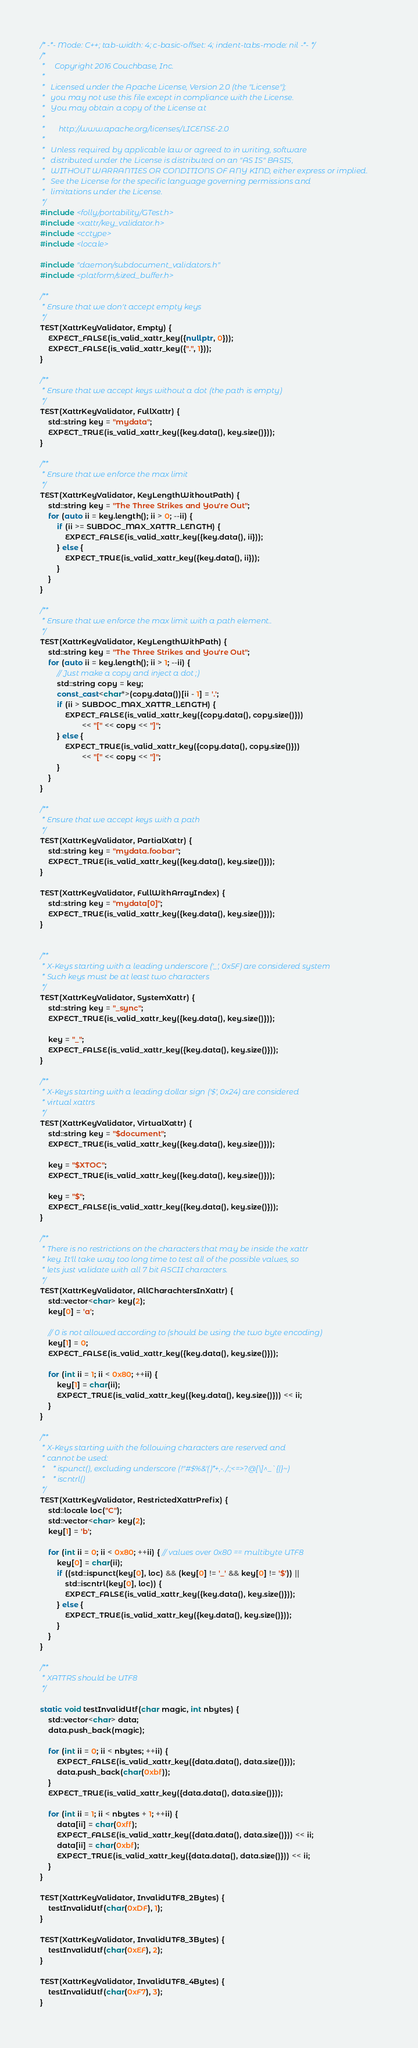<code> <loc_0><loc_0><loc_500><loc_500><_C++_>/* -*- Mode: C++; tab-width: 4; c-basic-offset: 4; indent-tabs-mode: nil -*- */
/*
 *     Copyright 2016 Couchbase, Inc.
 *
 *   Licensed under the Apache License, Version 2.0 (the "License");
 *   you may not use this file except in compliance with the License.
 *   You may obtain a copy of the License at
 *
 *       http://www.apache.org/licenses/LICENSE-2.0
 *
 *   Unless required by applicable law or agreed to in writing, software
 *   distributed under the License is distributed on an "AS IS" BASIS,
 *   WITHOUT WARRANTIES OR CONDITIONS OF ANY KIND, either express or implied.
 *   See the License for the specific language governing permissions and
 *   limitations under the License.
 */
#include <folly/portability/GTest.h>
#include <xattr/key_validator.h>
#include <cctype>
#include <locale>

#include "daemon/subdocument_validators.h"
#include <platform/sized_buffer.h>

/**
 * Ensure that we don't accept empty keys
 */
TEST(XattrKeyValidator, Empty) {
    EXPECT_FALSE(is_valid_xattr_key({nullptr, 0}));
    EXPECT_FALSE(is_valid_xattr_key({".", 1}));
}

/**
 * Ensure that we accept keys without a dot (the path is empty)
 */
TEST(XattrKeyValidator, FullXattr) {
    std::string key = "mydata";
    EXPECT_TRUE(is_valid_xattr_key({key.data(), key.size()}));
}

/**
 * Ensure that we enforce the max limit
 */
TEST(XattrKeyValidator, KeyLengthWithoutPath) {
    std::string key = "The Three Strikes and You're Out";
    for (auto ii = key.length(); ii > 0; --ii) {
        if (ii >= SUBDOC_MAX_XATTR_LENGTH) {
            EXPECT_FALSE(is_valid_xattr_key({key.data(), ii}));
        } else {
            EXPECT_TRUE(is_valid_xattr_key({key.data(), ii}));
        }
    }
}

/**
 * Ensure that we enforce the max limit with a path element..
 */
TEST(XattrKeyValidator, KeyLengthWithPath) {
    std::string key = "The Three Strikes and You're Out";
    for (auto ii = key.length(); ii > 1; --ii) {
        // Just make a copy and inject a dot ;)
        std::string copy = key;
        const_cast<char*>(copy.data())[ii - 1] = '.';
        if (ii > SUBDOC_MAX_XATTR_LENGTH) {
            EXPECT_FALSE(is_valid_xattr_key({copy.data(), copy.size()}))
                    << "[" << copy << "]";
        } else {
            EXPECT_TRUE(is_valid_xattr_key({copy.data(), copy.size()}))
                    << "[" << copy << "]";
        }
    }
}

/**
 * Ensure that we accept keys with a path
 */
TEST(XattrKeyValidator, PartialXattr) {
    std::string key = "mydata.foobar";
    EXPECT_TRUE(is_valid_xattr_key({key.data(), key.size()}));
}

TEST(XattrKeyValidator, FullWithArrayIndex) {
    std::string key = "mydata[0]";
    EXPECT_TRUE(is_valid_xattr_key({key.data(), key.size()}));
}


/**
 * X-Keys starting with a leading underscore ('_', 0x5F) are considered system
 * Such keys must be at least two characters
 */
TEST(XattrKeyValidator, SystemXattr) {
    std::string key = "_sync";
    EXPECT_TRUE(is_valid_xattr_key({key.data(), key.size()}));

    key = "_";
    EXPECT_FALSE(is_valid_xattr_key({key.data(), key.size()}));
}

/**
 * X-Keys starting with a leading dollar sign ('$', 0x24) are considered
 * virtual xattrs
 */
TEST(XattrKeyValidator, VirtualXattr) {
    std::string key = "$document";
    EXPECT_TRUE(is_valid_xattr_key({key.data(), key.size()}));

    key = "$XTOC";
    EXPECT_TRUE(is_valid_xattr_key({key.data(), key.size()}));

    key = "$";
    EXPECT_FALSE(is_valid_xattr_key({key.data(), key.size()}));
}

/**
 * There is no restrictions on the characters that may be inside the xattr
 * key. It'll take way too long time to test all of the possible values, so
 * lets just validate with all 7 bit ASCII characters.
 */
TEST(XattrKeyValidator, AllCharachtersInXattr) {
    std::vector<char> key(2);
    key[0] = 'a';

    // 0 is not allowed according to (should be using the two byte encoding)
    key[1] = 0;
    EXPECT_FALSE(is_valid_xattr_key({key.data(), key.size()}));

    for (int ii = 1; ii < 0x80; ++ii) {
        key[1] = char(ii);
        EXPECT_TRUE(is_valid_xattr_key({key.data(), key.size()})) << ii;
    }
}

/**
 * X-Keys starting with the following characters are reserved and
 * cannot be used:
 *    * ispunct(), excluding underscore (!"#$%&'()*+,-./:;<=>?@[\]^_`{|}~)
 *    * iscntrl()
 */
TEST(XattrKeyValidator, RestrictedXattrPrefix) {
    std::locale loc("C");
    std::vector<char> key(2);
    key[1] = 'b';

    for (int ii = 0; ii < 0x80; ++ii) { // values over 0x80 == multibyte UTF8
        key[0] = char(ii);
        if ((std::ispunct(key[0], loc) && (key[0] != '_' && key[0] != '$')) ||
            std::iscntrl(key[0], loc)) {
            EXPECT_FALSE(is_valid_xattr_key({key.data(), key.size()}));
        } else {
            EXPECT_TRUE(is_valid_xattr_key({key.data(), key.size()}));
        }
    }
}

/**
 * XATTRS should be UTF8
 */

static void testInvalidUtf(char magic, int nbytes) {
    std::vector<char> data;
    data.push_back(magic);

    for (int ii = 0; ii < nbytes; ++ii) {
        EXPECT_FALSE(is_valid_xattr_key({data.data(), data.size()}));
        data.push_back(char(0xbf));
    }
    EXPECT_TRUE(is_valid_xattr_key({data.data(), data.size()}));

    for (int ii = 1; ii < nbytes + 1; ++ii) {
        data[ii] = char(0xff);
        EXPECT_FALSE(is_valid_xattr_key({data.data(), data.size()})) << ii;
        data[ii] = char(0xbf);
        EXPECT_TRUE(is_valid_xattr_key({data.data(), data.size()})) << ii;
    }
}

TEST(XattrKeyValidator, InvalidUTF8_2Bytes) {
    testInvalidUtf(char(0xDF), 1);
}

TEST(XattrKeyValidator, InvalidUTF8_3Bytes) {
    testInvalidUtf(char(0xEF), 2);
}

TEST(XattrKeyValidator, InvalidUTF8_4Bytes) {
    testInvalidUtf(char(0xF7), 3);
}
</code> 